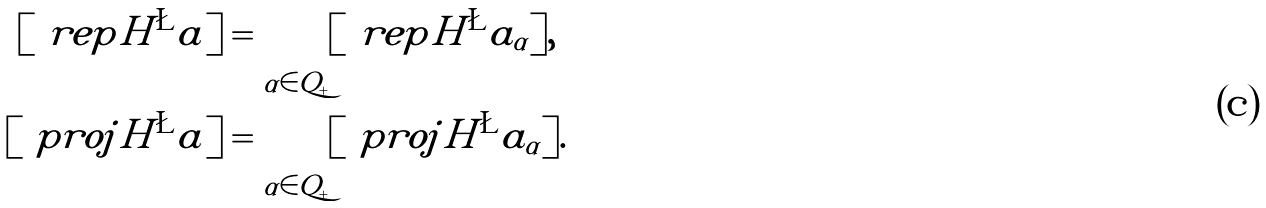<formula> <loc_0><loc_0><loc_500><loc_500>[ \ r e p { H ^ { \L } a } ] & = \bigoplus _ { \alpha \in Q _ { + } } [ \ r e p { H ^ { \L } a _ { \alpha } } ] , \\ [ \ p r o j { H ^ { \L } a } ] & = \bigoplus _ { \alpha \in Q _ { + } } [ \ p r o j { H ^ { \L } a _ { \alpha } } ] .</formula> 